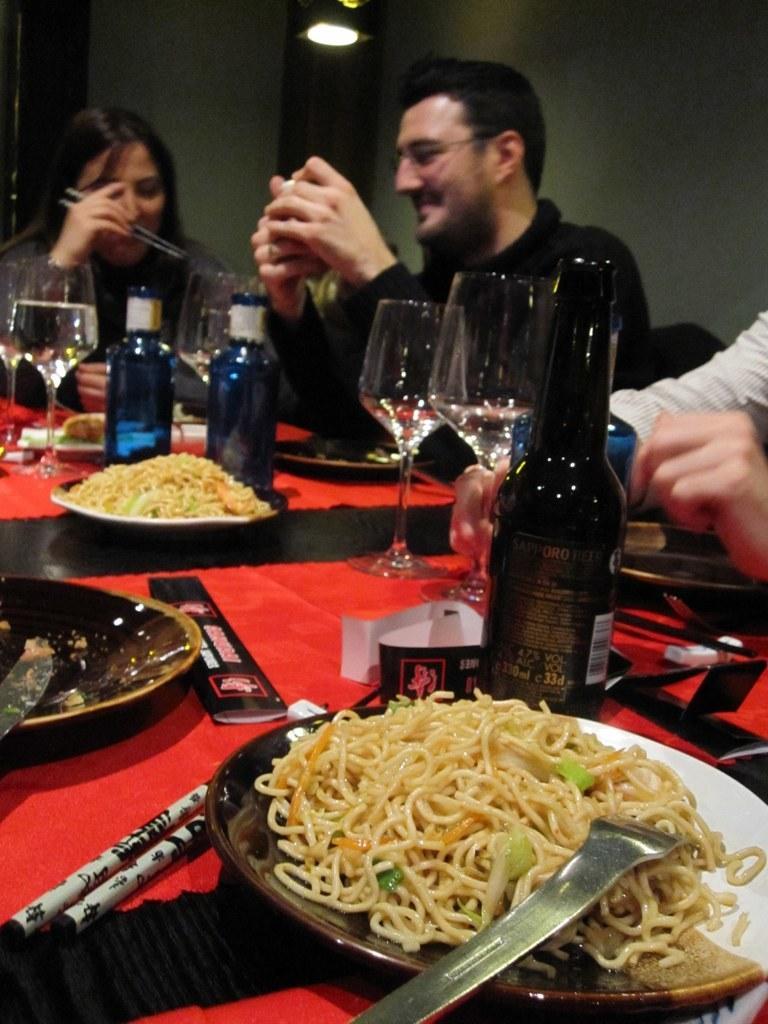Could you give a brief overview of what you see in this image? In this picture we can see a plate, food, bottles, glasses on the table and also we can see three people are seated on the chair in front of the table. 